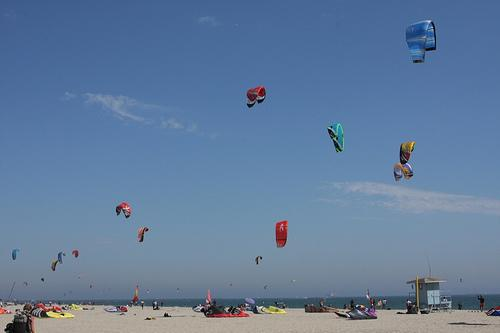What is the building for? Please explain your reasoning. lifeguard. The building gives a good vantage of the beach, while protecting the person from the elements. 